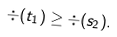Convert formula to latex. <formula><loc_0><loc_0><loc_500><loc_500>\div ( t _ { 1 } ) \geq \div ( s _ { 2 } ) .</formula> 